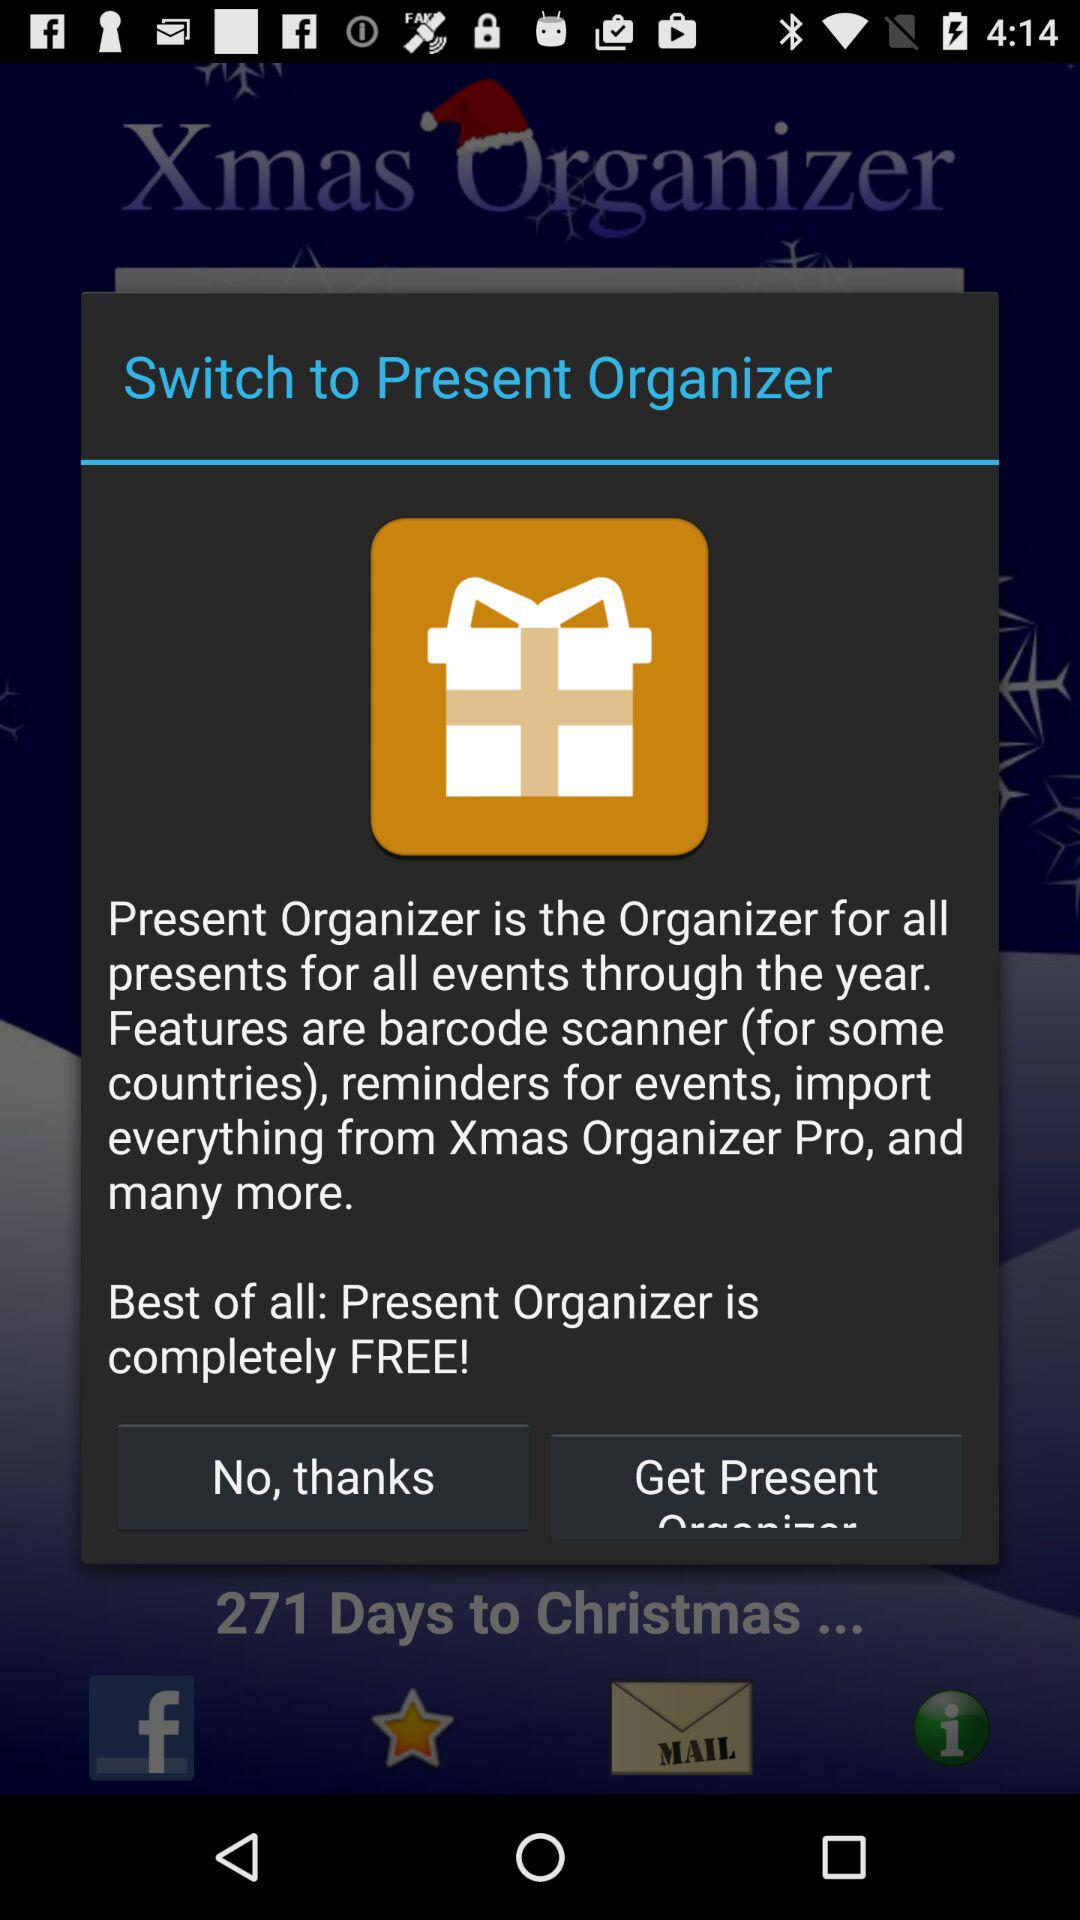Is "Present Organizer" free or paid? "Present Organizer" is free. 